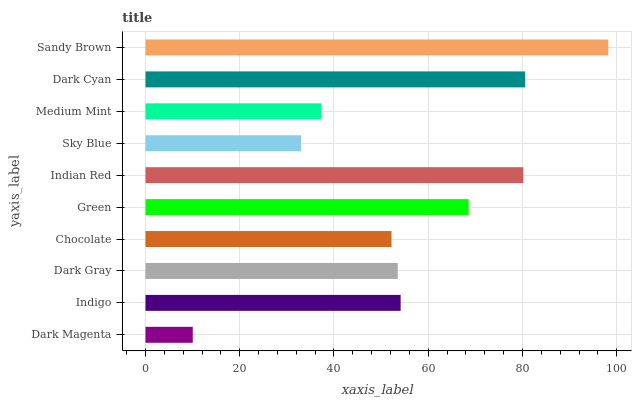Is Dark Magenta the minimum?
Answer yes or no. Yes. Is Sandy Brown the maximum?
Answer yes or no. Yes. Is Indigo the minimum?
Answer yes or no. No. Is Indigo the maximum?
Answer yes or no. No. Is Indigo greater than Dark Magenta?
Answer yes or no. Yes. Is Dark Magenta less than Indigo?
Answer yes or no. Yes. Is Dark Magenta greater than Indigo?
Answer yes or no. No. Is Indigo less than Dark Magenta?
Answer yes or no. No. Is Indigo the high median?
Answer yes or no. Yes. Is Dark Gray the low median?
Answer yes or no. Yes. Is Indian Red the high median?
Answer yes or no. No. Is Indigo the low median?
Answer yes or no. No. 